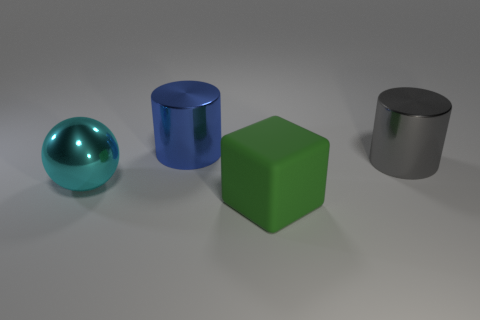Do the object on the right side of the matte block and the big blue cylinder have the same material?
Provide a succinct answer. Yes. The big metallic object that is on the right side of the cube has what shape?
Offer a terse response. Cylinder. What number of cyan spheres have the same size as the green rubber object?
Your response must be concise. 1. What size is the blue metal cylinder?
Your response must be concise. Large. How many gray things are left of the large blue metallic cylinder?
Your response must be concise. 0. There is a large cyan object that is made of the same material as the blue object; what is its shape?
Your response must be concise. Sphere. Is the number of shiny spheres that are right of the gray object less than the number of large gray metal things on the left side of the large sphere?
Your response must be concise. No. Are there more large cylinders than big cyan things?
Provide a succinct answer. Yes. What is the ball made of?
Provide a short and direct response. Metal. The big metal cylinder that is to the right of the blue object is what color?
Your answer should be compact. Gray. 